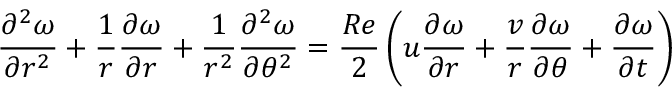<formula> <loc_0><loc_0><loc_500><loc_500>\frac { \partial ^ { 2 } \omega } { \partial r ^ { 2 } } + \frac { 1 } { r } \frac { \partial \omega } { \partial r } + \frac { 1 } { r ^ { 2 } } \frac { \partial ^ { 2 } \omega } { \partial \theta ^ { 2 } } = \frac { R e } { 2 } \left ( u \frac { \partial \omega } { \partial r } + \frac { v } { r } \frac { \partial \omega } { \partial \theta } + \frac { \partial \omega } { \partial t } \right )</formula> 